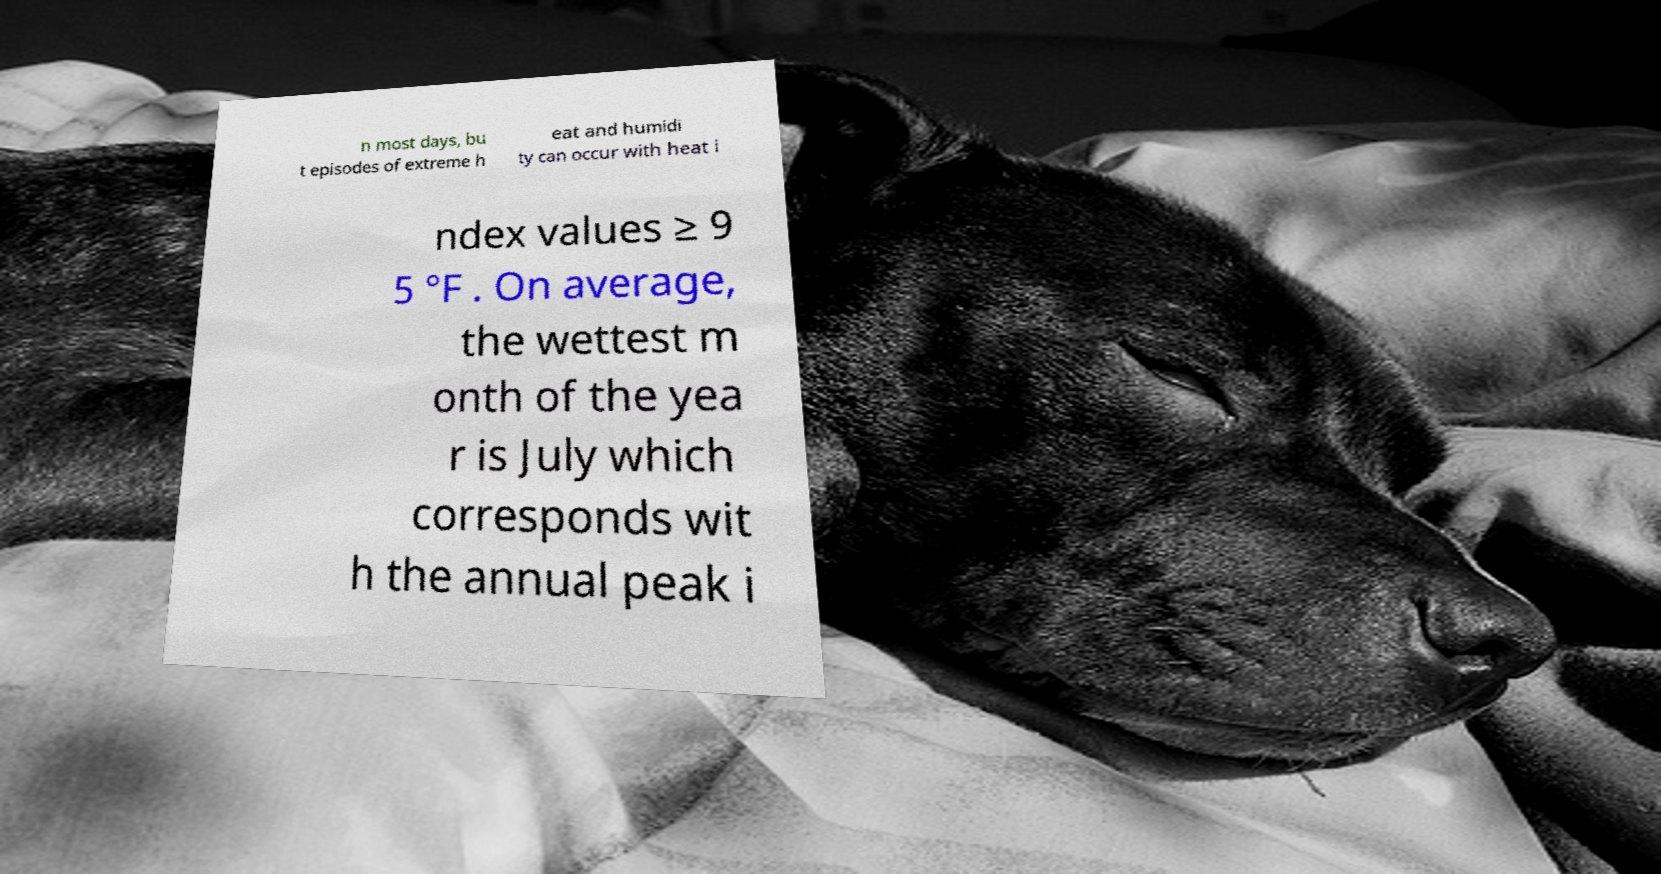For documentation purposes, I need the text within this image transcribed. Could you provide that? n most days, bu t episodes of extreme h eat and humidi ty can occur with heat i ndex values ≥ 9 5 °F . On average, the wettest m onth of the yea r is July which corresponds wit h the annual peak i 